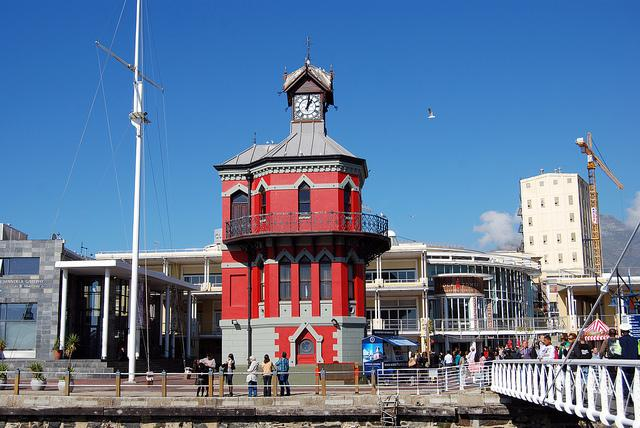What color are the rectangular bricks on the very bottom of the tower? gray 